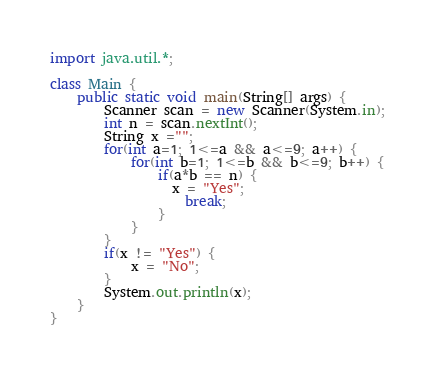<code> <loc_0><loc_0><loc_500><loc_500><_Java_>import java.util.*;

class Main {
    public static void main(String[] args) {
        Scanner scan = new Scanner(System.in);
        int n = scan.nextInt();
        String x ="";
        for(int a=1; 1<=a && a<=9; a++) {
            for(int b=1; 1<=b && b<=9; b++) {
                if(a*b == n) {
                  x = "Yes";  
                    break;
                }
            }
        }
        if(x != "Yes") {
            x = "No";
        }
        System.out.println(x);
    }
}</code> 